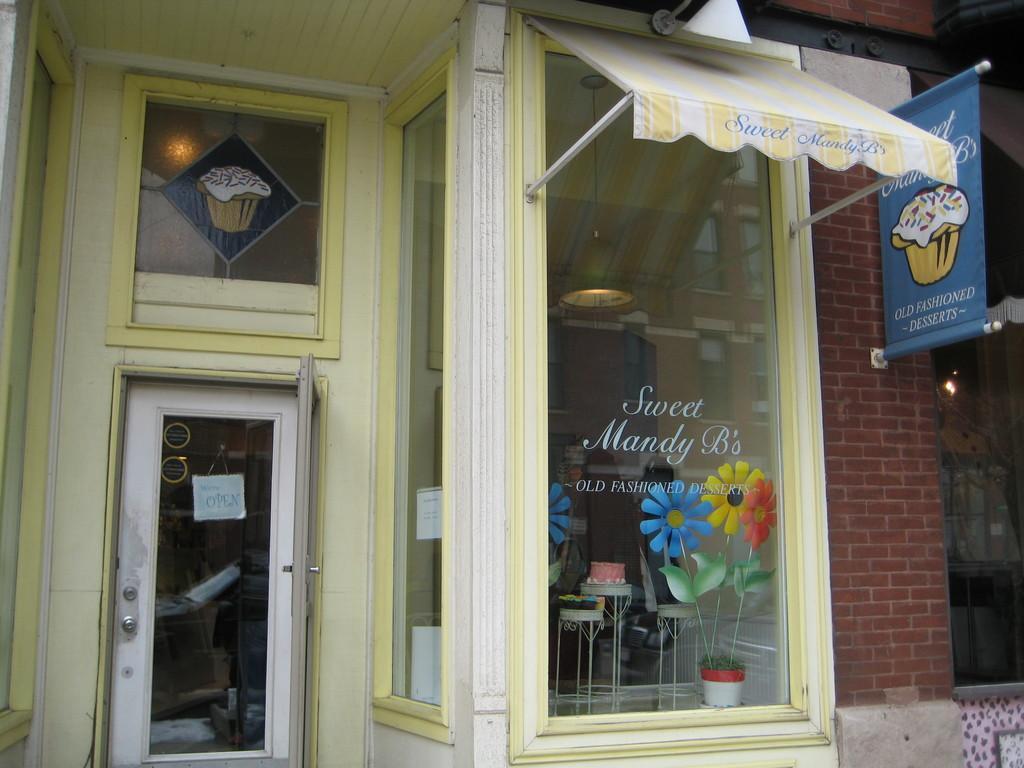Describe this image in one or two sentences. In the foreground of this image, there is a shop where we can see door, a glass window, a banner, a small tent to the glass window and inside there are cakes on the stools. 